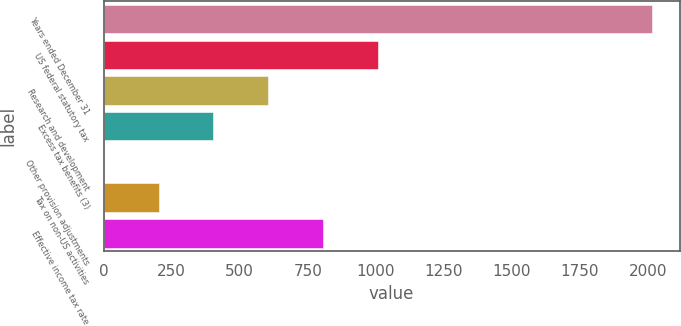<chart> <loc_0><loc_0><loc_500><loc_500><bar_chart><fcel>Years ended December 31<fcel>US federal statutory tax<fcel>Research and development<fcel>Excess tax benefits (3)<fcel>Other provision adjustments<fcel>Tax on non-US activities<fcel>Effective income tax rate<nl><fcel>2016<fcel>1008.15<fcel>605.01<fcel>403.44<fcel>0.3<fcel>201.87<fcel>806.58<nl></chart> 